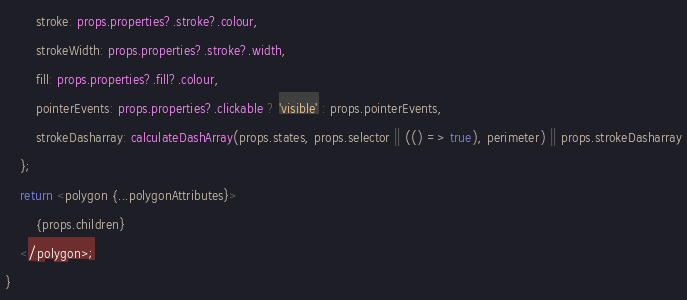<code> <loc_0><loc_0><loc_500><loc_500><_TypeScript_>        stroke: props.properties?.stroke?.colour,
        strokeWidth: props.properties?.stroke?.width,
        fill: props.properties?.fill?.colour,
        pointerEvents: props.properties?.clickable ? 'visible' : props.pointerEvents,
        strokeDasharray: calculateDashArray(props.states, props.selector || (() => true), perimeter) || props.strokeDasharray
    };
    return <polygon {...polygonAttributes}>
        {props.children}
    </polygon>;
}
</code> 